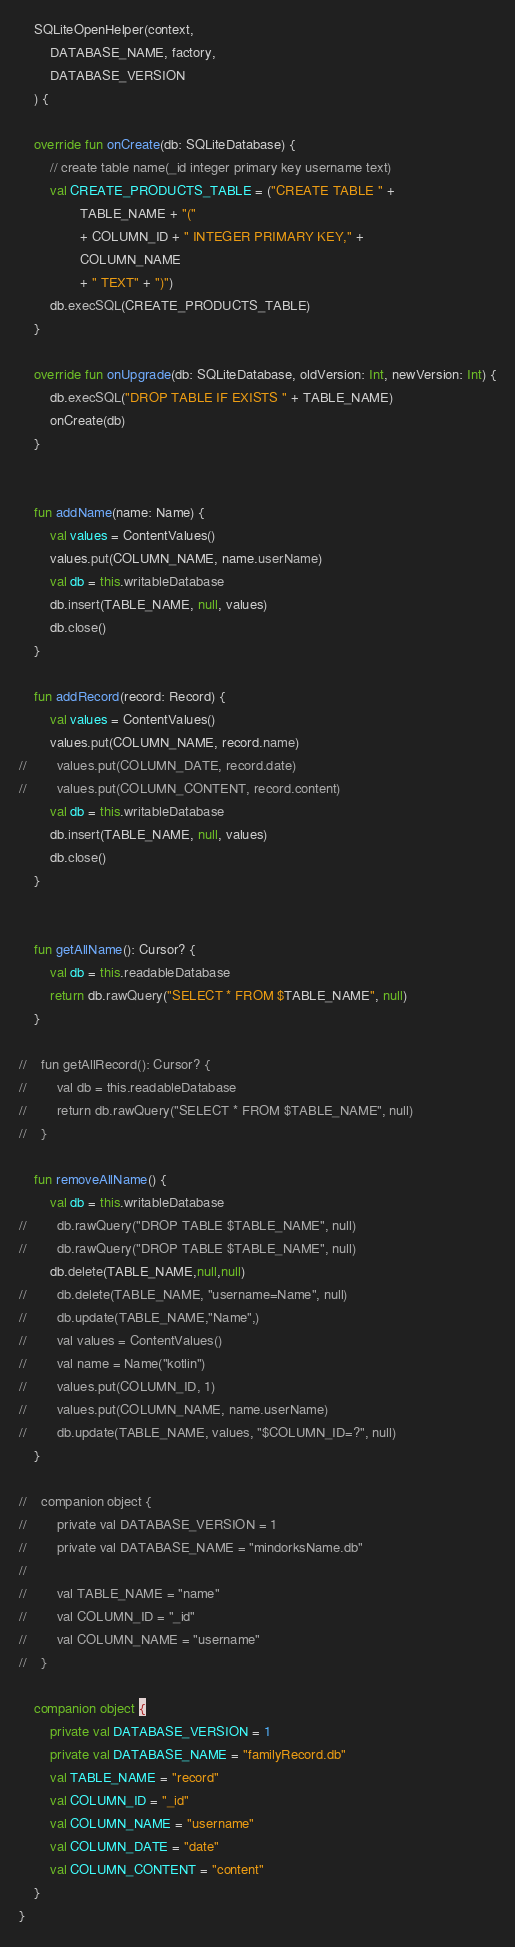<code> <loc_0><loc_0><loc_500><loc_500><_Kotlin_>    SQLiteOpenHelper(context,
        DATABASE_NAME, factory,
        DATABASE_VERSION
    ) {

    override fun onCreate(db: SQLiteDatabase) {
        // create table name(_id integer primary key username text)
        val CREATE_PRODUCTS_TABLE = ("CREATE TABLE " +
                TABLE_NAME + "("
                + COLUMN_ID + " INTEGER PRIMARY KEY," +
                COLUMN_NAME
                + " TEXT" + ")")
        db.execSQL(CREATE_PRODUCTS_TABLE)
    }

    override fun onUpgrade(db: SQLiteDatabase, oldVersion: Int, newVersion: Int) {
        db.execSQL("DROP TABLE IF EXISTS " + TABLE_NAME)
        onCreate(db)
    }


    fun addName(name: Name) {
        val values = ContentValues()
        values.put(COLUMN_NAME, name.userName)
        val db = this.writableDatabase
        db.insert(TABLE_NAME, null, values)
        db.close()
    }

    fun addRecord(record: Record) {
        val values = ContentValues()
        values.put(COLUMN_NAME, record.name)
//        values.put(COLUMN_DATE, record.date)
//        values.put(COLUMN_CONTENT, record.content)
        val db = this.writableDatabase
        db.insert(TABLE_NAME, null, values)
        db.close()
    }


    fun getAllName(): Cursor? {
        val db = this.readableDatabase
        return db.rawQuery("SELECT * FROM $TABLE_NAME", null)
    }

//    fun getAllRecord(): Cursor? {
//        val db = this.readableDatabase
//        return db.rawQuery("SELECT * FROM $TABLE_NAME", null)
//    }

    fun removeAllName() {
        val db = this.writableDatabase
//        db.rawQuery("DROP TABLE $TABLE_NAME", null)
//        db.rawQuery("DROP TABLE $TABLE_NAME", null)
        db.delete(TABLE_NAME,null,null)
//        db.delete(TABLE_NAME, "username=Name", null)
//        db.update(TABLE_NAME,"Name",)
//        val values = ContentValues()
//        val name = Name("kotlin")
//        values.put(COLUMN_ID, 1)
//        values.put(COLUMN_NAME, name.userName)
//        db.update(TABLE_NAME, values, "$COLUMN_ID=?", null)
    }

//    companion object {
//        private val DATABASE_VERSION = 1
//        private val DATABASE_NAME = "mindorksName.db"
//
//        val TABLE_NAME = "name"
//        val COLUMN_ID = "_id"
//        val COLUMN_NAME = "username"
//    }

    companion object {
        private val DATABASE_VERSION = 1
        private val DATABASE_NAME = "familyRecord.db"
        val TABLE_NAME = "record"
        val COLUMN_ID = "_id"
        val COLUMN_NAME = "username"
        val COLUMN_DATE = "date"
        val COLUMN_CONTENT = "content"
    }
}</code> 